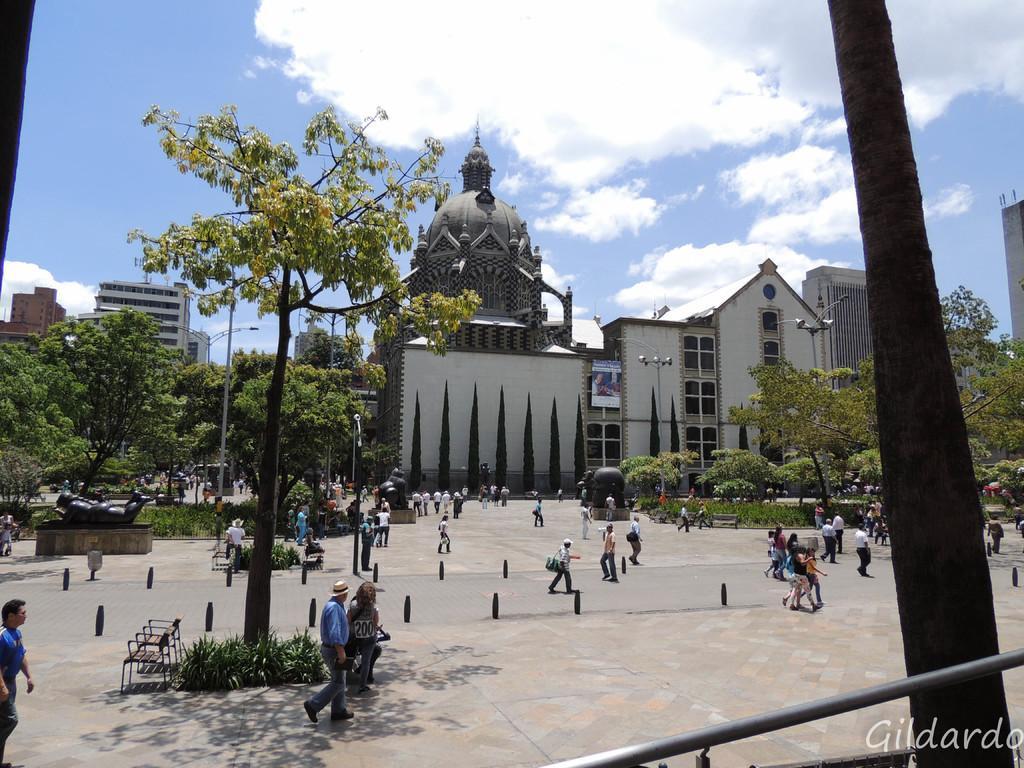Describe this image in one or two sentences. In this in the middle a man is walking, he wore a hat, shirt, trouser. Beside him a person is sitting under the tree and few people are walking on the road. There are buildings, at the top it is the sky. 